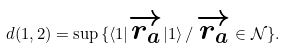Convert formula to latex. <formula><loc_0><loc_0><loc_500><loc_500>d ( 1 , 2 ) = \sup \, \{ \langle 1 | { \overrightarrow { r _ { a } } } | 1 \rangle \, / \, { \overrightarrow { r _ { a } } } \in \mathcal { N } \} .</formula> 